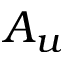<formula> <loc_0><loc_0><loc_500><loc_500>A _ { u }</formula> 